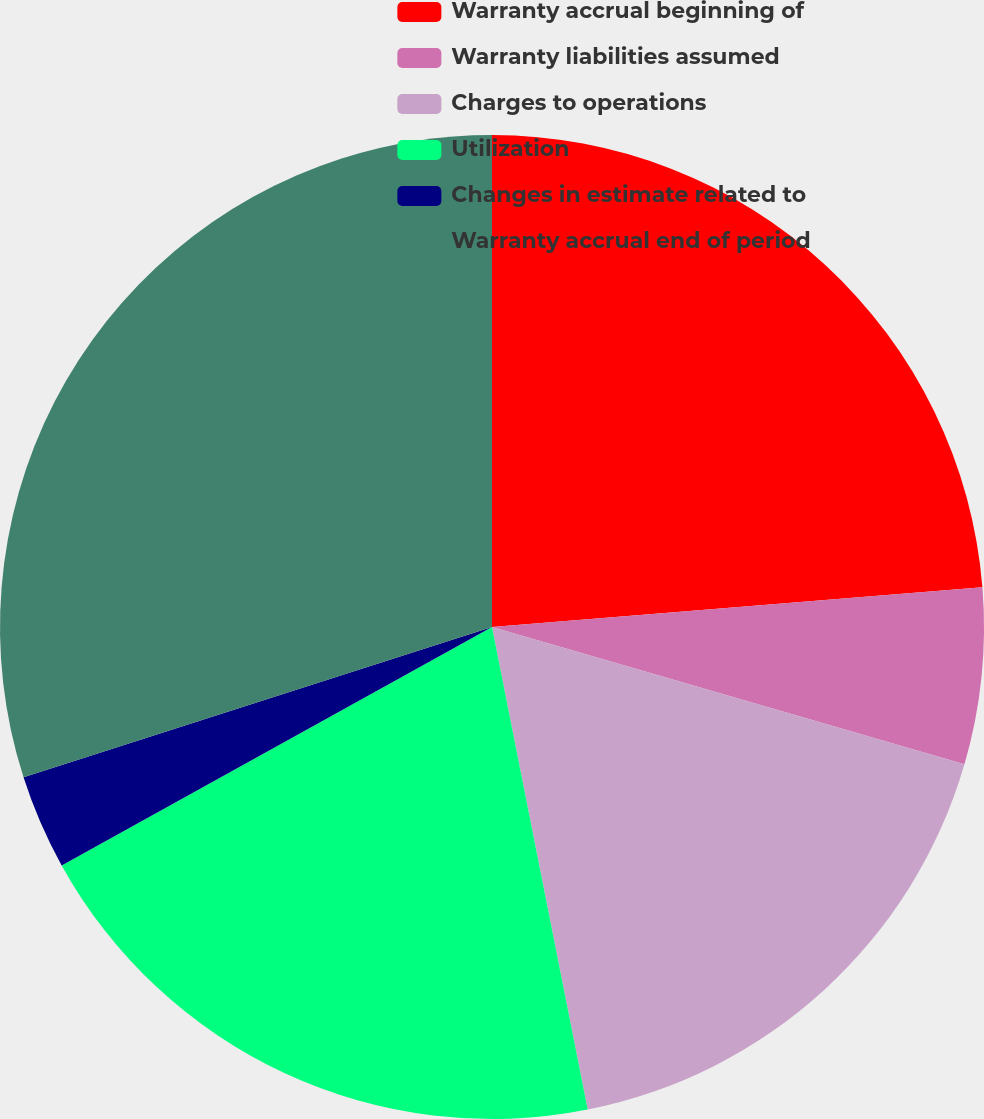Convert chart to OTSL. <chart><loc_0><loc_0><loc_500><loc_500><pie_chart><fcel>Warranty accrual beginning of<fcel>Warranty liabilities assumed<fcel>Charges to operations<fcel>Utilization<fcel>Changes in estimate related to<fcel>Warranty accrual end of period<nl><fcel>23.71%<fcel>5.79%<fcel>17.38%<fcel>20.06%<fcel>3.11%<fcel>29.94%<nl></chart> 